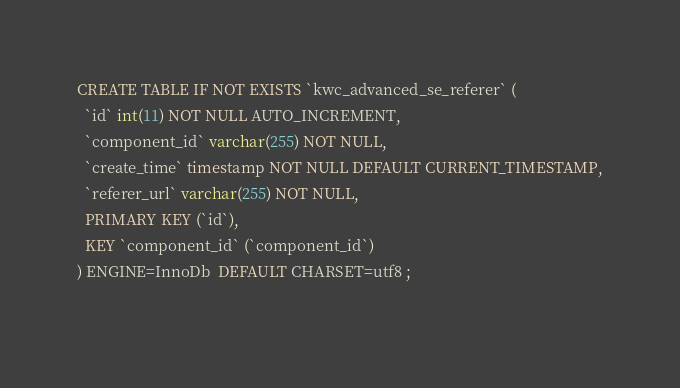Convert code to text. <code><loc_0><loc_0><loc_500><loc_500><_SQL_>CREATE TABLE IF NOT EXISTS `kwc_advanced_se_referer` (
  `id` int(11) NOT NULL AUTO_INCREMENT,
  `component_id` varchar(255) NOT NULL,
  `create_time` timestamp NOT NULL DEFAULT CURRENT_TIMESTAMP,
  `referer_url` varchar(255) NOT NULL,
  PRIMARY KEY (`id`),
  KEY `component_id` (`component_id`)
) ENGINE=InnoDb  DEFAULT CHARSET=utf8 ;
 </code> 